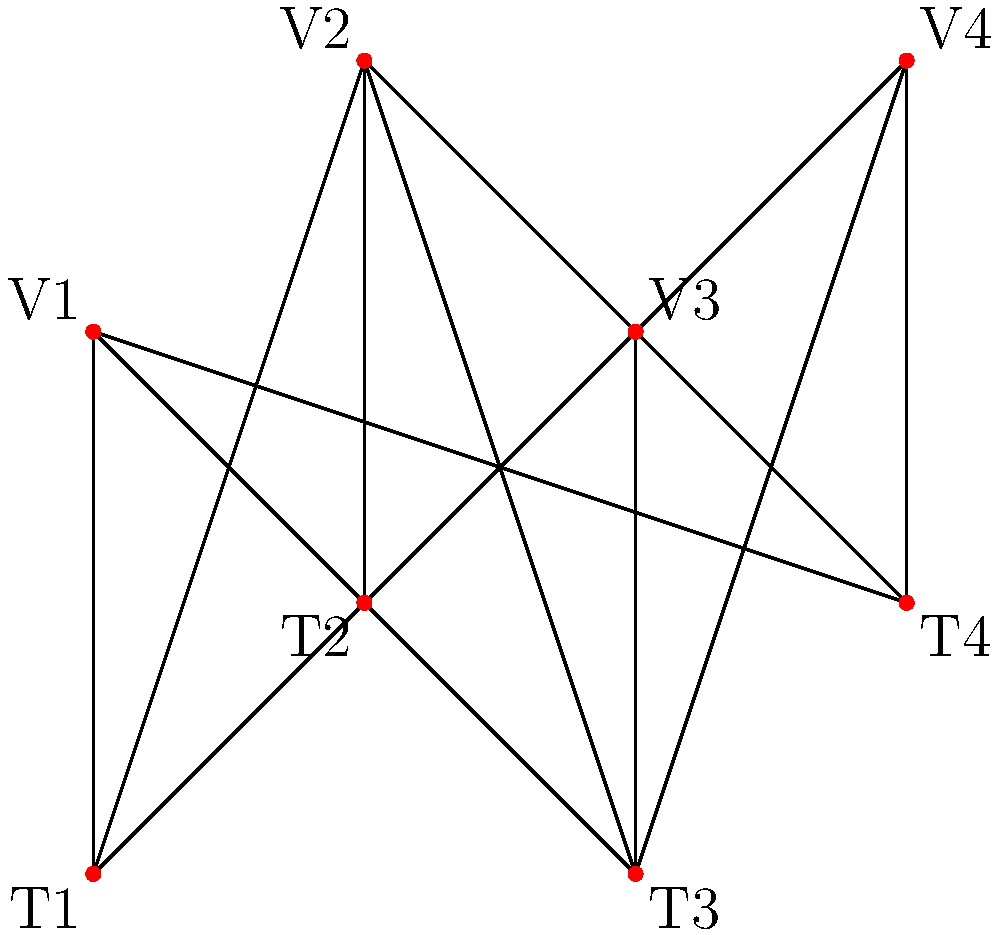In a lacrosse tournament, there are 4 teams (T1, T2, T3, T4) and 4 venues (V1, V2, V3, V4). The graph above represents the possible assignments of teams to venues. What is the maximum number of games that can be scheduled simultaneously, ensuring that each team plays at most one game and each venue hosts at most one game? To solve this problem, we need to find the maximum matching in the bipartite graph. Here's a step-by-step approach:

1. Identify the bipartite graph: The graph is bipartite with teams on one side and venues on the other.

2. Understand the constraints:
   - Each team can play at most one game (be matched to one venue).
   - Each venue can host at most one game (be matched to one team).

3. Find the maximum matching:
   - Start with T1: Match T1 to V1
   - Move to T2: Match T2 to V2
   - For T3: Match T3 to V3
   - For T4: Match T4 to V4

4. Verify the matching:
   - All teams are matched to a unique venue.
   - All venues are matched to a unique team.
   - No more matches can be added without violating the constraints.

5. Count the matches:
   The maximum matching contains 4 edges, representing 4 simultaneous games.

This solution corresponds to the maximum number of games that can be scheduled simultaneously, as we've utilized all available teams and venues without conflicts.
Answer: 4 